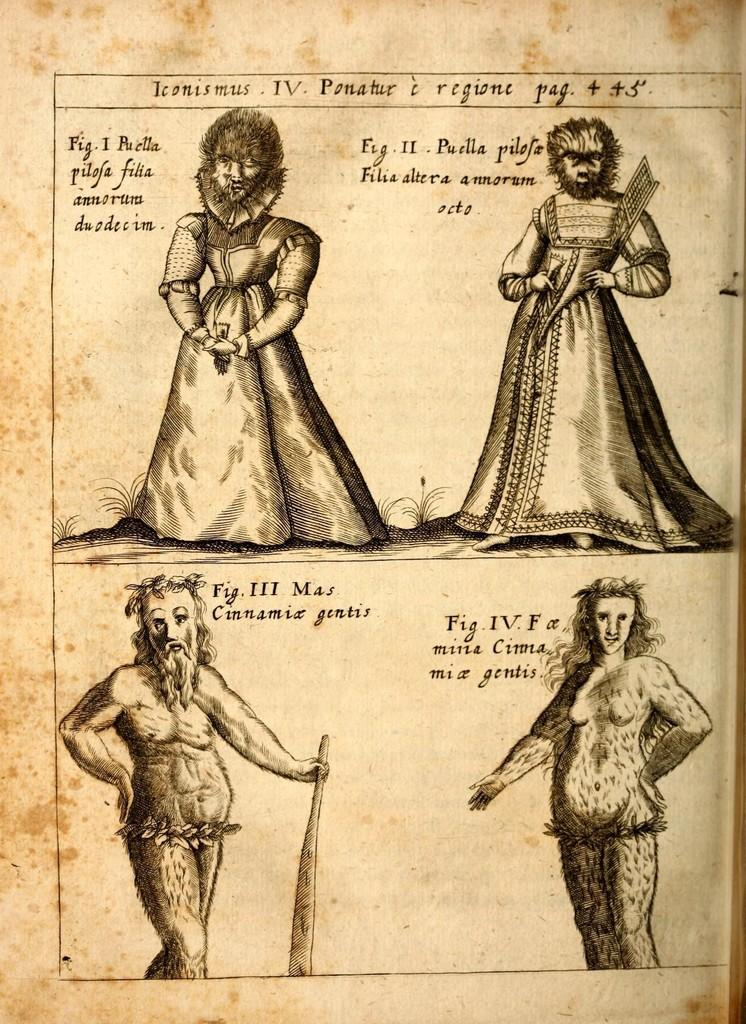What is present in the image related to written material? There is a paper in the image. What type of content is on the paper? The paper contains diagrams and text. How does the paper grip the water in the image? There is no water present in the image, and the paper is not gripping anything. 